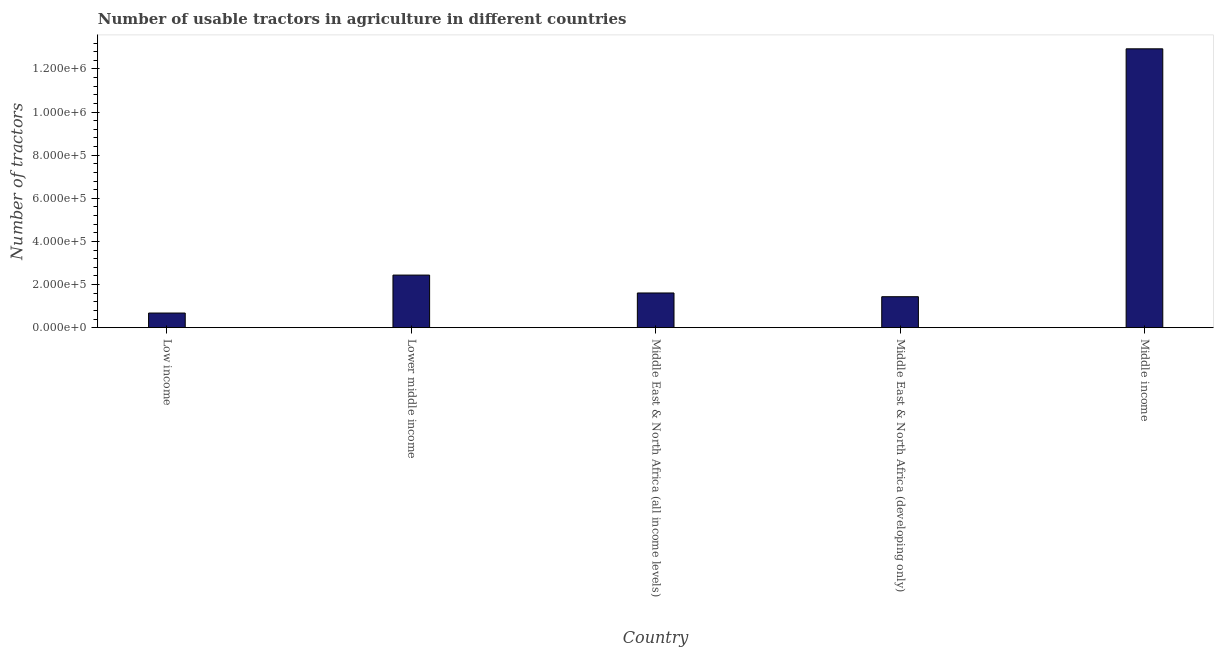Does the graph contain any zero values?
Offer a very short reply. No. Does the graph contain grids?
Offer a terse response. No. What is the title of the graph?
Ensure brevity in your answer.  Number of usable tractors in agriculture in different countries. What is the label or title of the Y-axis?
Your response must be concise. Number of tractors. What is the number of tractors in Lower middle income?
Make the answer very short. 2.44e+05. Across all countries, what is the maximum number of tractors?
Ensure brevity in your answer.  1.29e+06. Across all countries, what is the minimum number of tractors?
Your answer should be compact. 6.78e+04. In which country was the number of tractors minimum?
Keep it short and to the point. Low income. What is the sum of the number of tractors?
Give a very brief answer. 1.91e+06. What is the difference between the number of tractors in Middle East & North Africa (all income levels) and Middle East & North Africa (developing only)?
Provide a succinct answer. 1.73e+04. What is the average number of tractors per country?
Your response must be concise. 3.82e+05. What is the median number of tractors?
Your response must be concise. 1.61e+05. In how many countries, is the number of tractors greater than 40000 ?
Provide a short and direct response. 5. What is the ratio of the number of tractors in Lower middle income to that in Middle East & North Africa (developing only)?
Keep it short and to the point. 1.7. Is the number of tractors in Middle East & North Africa (developing only) less than that in Middle income?
Your response must be concise. Yes. Is the difference between the number of tractors in Middle East & North Africa (all income levels) and Middle East & North Africa (developing only) greater than the difference between any two countries?
Provide a succinct answer. No. What is the difference between the highest and the second highest number of tractors?
Keep it short and to the point. 1.05e+06. What is the difference between the highest and the lowest number of tractors?
Keep it short and to the point. 1.23e+06. What is the difference between two consecutive major ticks on the Y-axis?
Your response must be concise. 2.00e+05. What is the Number of tractors of Low income?
Keep it short and to the point. 6.78e+04. What is the Number of tractors in Lower middle income?
Your response must be concise. 2.44e+05. What is the Number of tractors of Middle East & North Africa (all income levels)?
Give a very brief answer. 1.61e+05. What is the Number of tractors in Middle East & North Africa (developing only)?
Provide a succinct answer. 1.44e+05. What is the Number of tractors of Middle income?
Your answer should be compact. 1.29e+06. What is the difference between the Number of tractors in Low income and Lower middle income?
Provide a succinct answer. -1.76e+05. What is the difference between the Number of tractors in Low income and Middle East & North Africa (all income levels)?
Your response must be concise. -9.31e+04. What is the difference between the Number of tractors in Low income and Middle East & North Africa (developing only)?
Provide a short and direct response. -7.57e+04. What is the difference between the Number of tractors in Low income and Middle income?
Your response must be concise. -1.23e+06. What is the difference between the Number of tractors in Lower middle income and Middle East & North Africa (all income levels)?
Give a very brief answer. 8.30e+04. What is the difference between the Number of tractors in Lower middle income and Middle East & North Africa (developing only)?
Offer a terse response. 1.00e+05. What is the difference between the Number of tractors in Lower middle income and Middle income?
Ensure brevity in your answer.  -1.05e+06. What is the difference between the Number of tractors in Middle East & North Africa (all income levels) and Middle East & North Africa (developing only)?
Your answer should be very brief. 1.73e+04. What is the difference between the Number of tractors in Middle East & North Africa (all income levels) and Middle income?
Ensure brevity in your answer.  -1.13e+06. What is the difference between the Number of tractors in Middle East & North Africa (developing only) and Middle income?
Offer a terse response. -1.15e+06. What is the ratio of the Number of tractors in Low income to that in Lower middle income?
Offer a very short reply. 0.28. What is the ratio of the Number of tractors in Low income to that in Middle East & North Africa (all income levels)?
Keep it short and to the point. 0.42. What is the ratio of the Number of tractors in Low income to that in Middle East & North Africa (developing only)?
Your answer should be compact. 0.47. What is the ratio of the Number of tractors in Low income to that in Middle income?
Make the answer very short. 0.05. What is the ratio of the Number of tractors in Lower middle income to that in Middle East & North Africa (all income levels)?
Provide a short and direct response. 1.52. What is the ratio of the Number of tractors in Lower middle income to that in Middle East & North Africa (developing only)?
Make the answer very short. 1.7. What is the ratio of the Number of tractors in Lower middle income to that in Middle income?
Provide a short and direct response. 0.19. What is the ratio of the Number of tractors in Middle East & North Africa (all income levels) to that in Middle East & North Africa (developing only)?
Your answer should be compact. 1.12. What is the ratio of the Number of tractors in Middle East & North Africa (all income levels) to that in Middle income?
Offer a terse response. 0.12. What is the ratio of the Number of tractors in Middle East & North Africa (developing only) to that in Middle income?
Give a very brief answer. 0.11. 